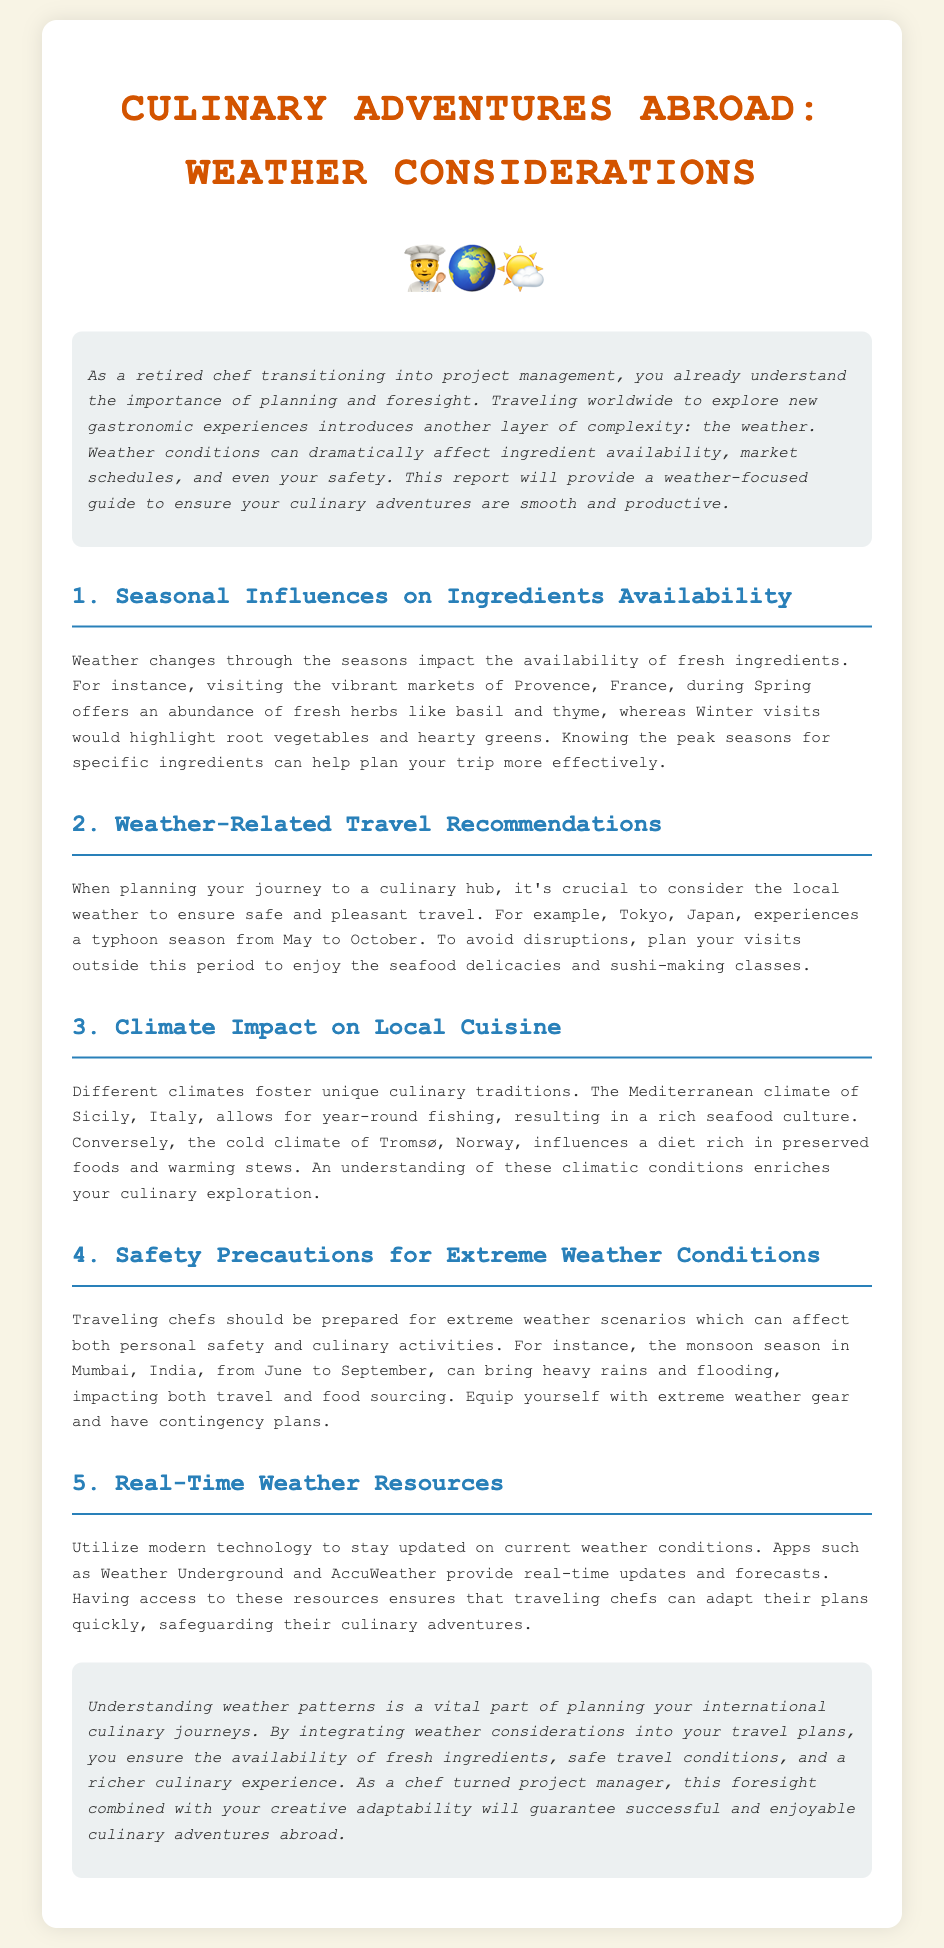What is the main focus of this report? The report focuses on how weather considerations can impact culinary adventures abroad.
Answer: Weather considerations What is a key seasonal factor affecting ingredient availability in Provence, France? The report mentions that Spring offers an abundance of fresh herbs.
Answer: Spring During which months does Tokyo experience its typhoon season? The report specifies that Tokyo's typhoon season is from May to October.
Answer: May to October What type of local cuisine is influenced by the Mediterranean climate in Sicily, Italy? The report indicates that the Mediterranean climate fosters a rich seafood culture.
Answer: Seafood culture What should traveling chefs equip themselves with during the monsoon season in Mumbai? The report advises traveling chefs to equip themselves with extreme weather gear.
Answer: Extreme weather gear How can modern technology help traveling chefs? The report states that apps like Weather Underground and AccuWeather provide real-time weather updates.
Answer: Real-time weather updates What is an example of extreme weather that may affect travel and food sourcing in Mumbai? The report mentions heavy rains and flooding during the monsoon season.
Answer: Heavy rains and flooding What is the impact of the cold climate in Tromsø, Norway, according to the report? The document indicates that the cold climate influences a diet rich in preserved foods and warming stews.
Answer: Preserved foods and warming stews What is the benefit of understanding weather patterns before traveling? The report explains that it ensures the availability of fresh ingredients and safe travel conditions.
Answer: Fresh ingredients and safe travel conditions 